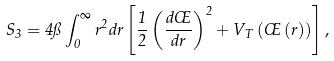<formula> <loc_0><loc_0><loc_500><loc_500>S _ { 3 } = 4 \pi \int _ { 0 } ^ { \infty } r ^ { 2 } d r \left [ \frac { 1 } { 2 } \left ( \frac { d \phi } { d r } \right ) ^ { 2 } + V _ { T } \left ( \phi \left ( r \right ) \right ) \right ] ,</formula> 